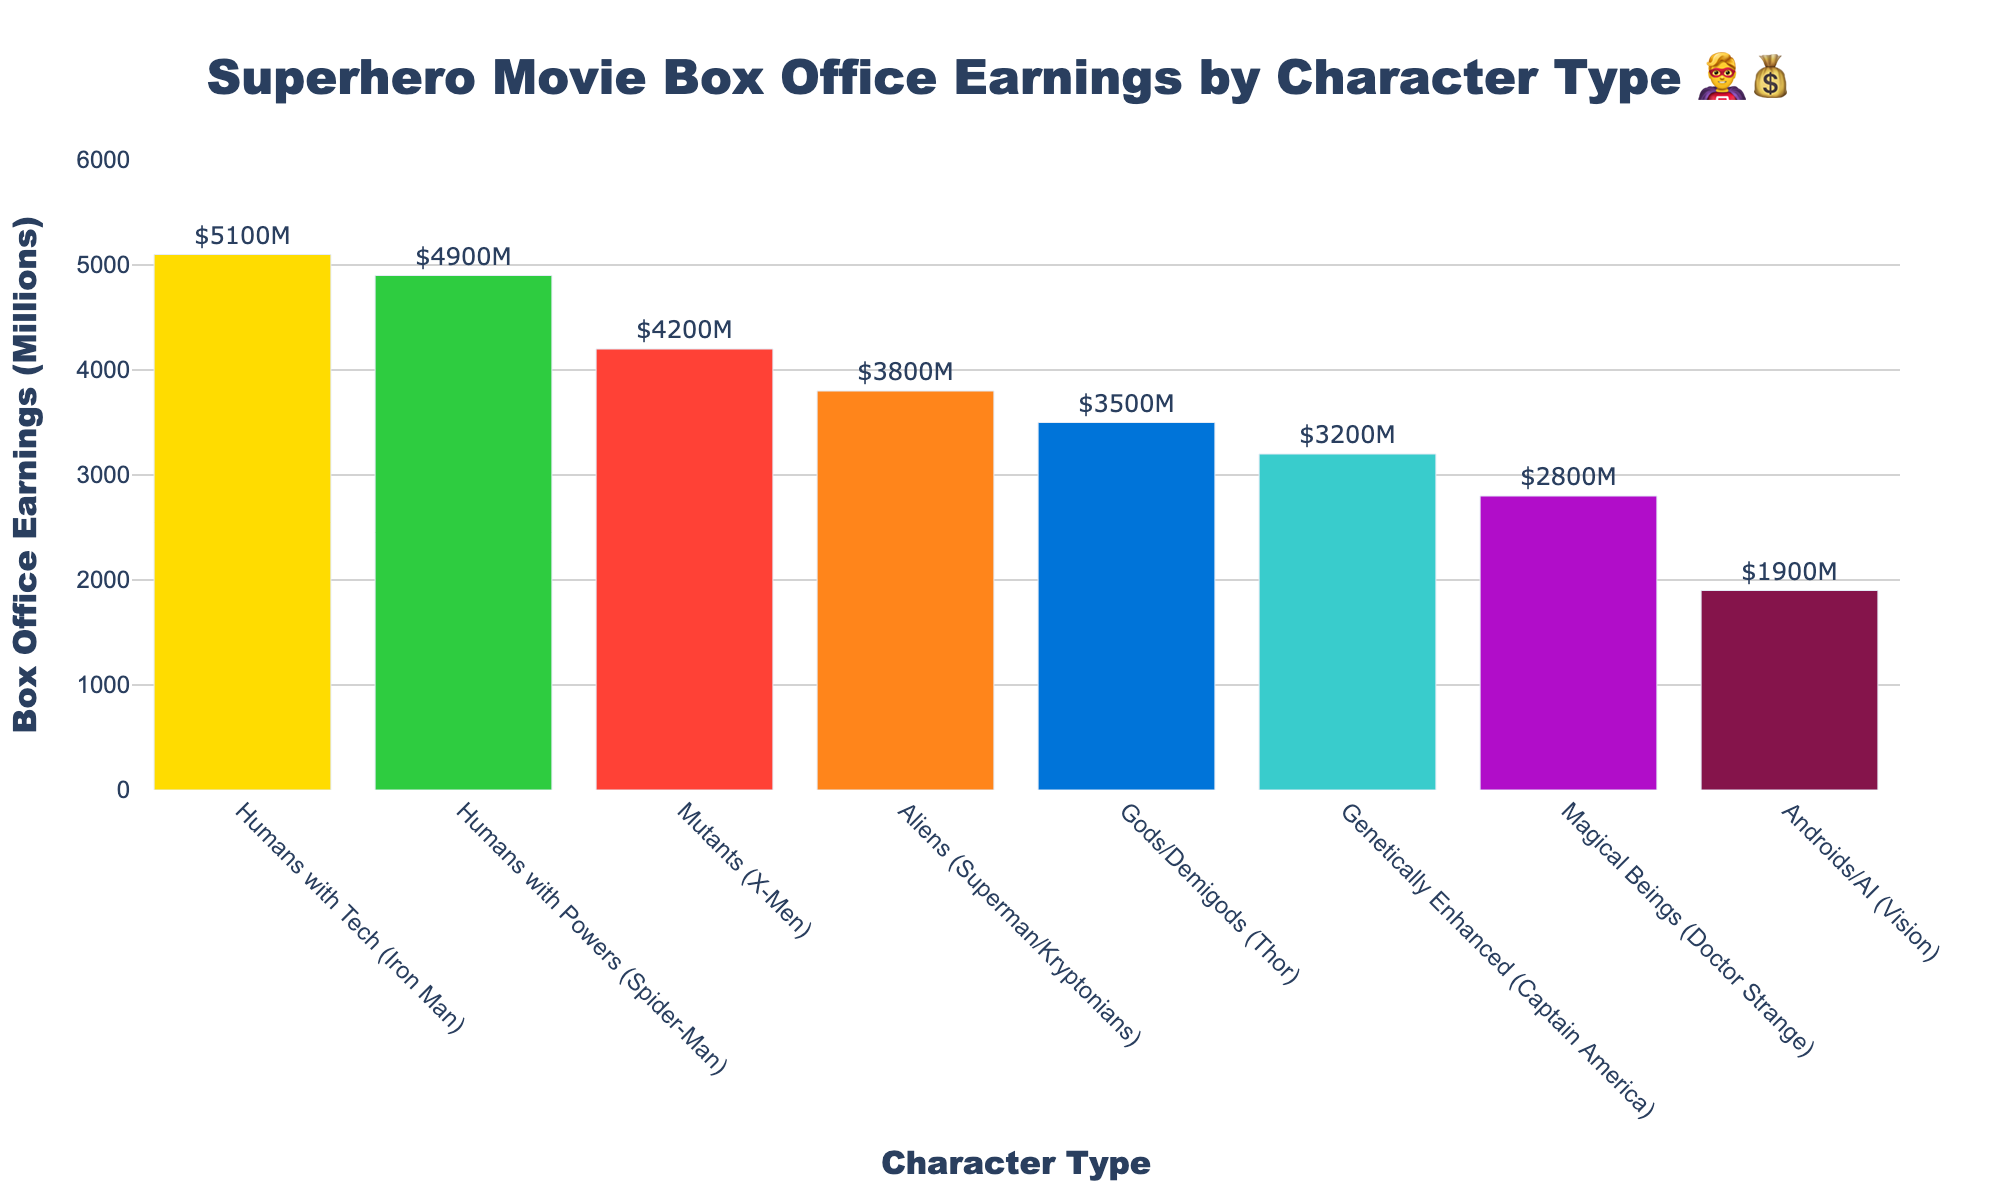What's the title of the chart? The title is usually found at the top of the chart, providing a summary of what the chart represents.
Answer: Superhero Movie Box Office Earnings by Character Type 🦸‍♂️💰 Which character type has the highest box office earnings? Looking at the bars representing different character types, the one with the highest bar represents the highest earnings.
Answer: Humans with Tech (Iron Man) How much did movies featuring Androids/AI earn at the box office? Identify the bar labeled "Androids/AI (Vision)" and look for the corresponding earnings value.
Answer: $1900 million What's the difference in box office earnings between Gods/Demigods and Genetically Enhanced characters? Subtract the earnings of Genetically Enhanced characters from Gods/Demigods earnings. Gods/Demigods earned $3500M and Genetically Enhanced earned $3200M.
Answer: $300 million Which three character types have the lowest box office earnings? Find the bottom three bars in terms of height and read the character types and their earnings. The lowest three are identified as: "Androids/AI (Vision)", "Magical Beings (Doctor Strange)", and "Genetically Enhanced (Captain America)".
Answer: Androids/AI, Magical Beings, Genetically Enhanced What is the average box office earnings across all character types? Add all the earnings and divide by the number of character types. The total earnings are: 4200 + 3800 + 5100 + 4900 + 3500 + 2800 + 1900 + 3200 = 29400 million. There are 8 character types. So, the average is 29400 / 8.
Answer: $3675 million Which character type earned more at the box office: Mutants or Aliens? Compare the bar heights (or values) for Mutants ("Mutants (X-Men)" was $4200M) and Aliens ("Aliens (Superman/Kryptonians)" was $3800M).
Answer: Mutants How does the box office earnings of Magical Beings compare to that of Humans with Powers? Compare the bar heights for "Magical Beings (Doctor Strange)" ($2800M) and "Humans with Powers (Spider-Man)" ($4900M).
Answer: $2100 million less Which character type has the median box office earnings, and what is that amount? Sort the earnings in ascending order and find the middle value. Sorted values: 1900, 2800, 3200, 3500, 3800, 4200, 4900, 5100. The median value is the average of the middle two values: (3500 + 3800)/2.
Answer: Gods/Demigods, $3650 million 